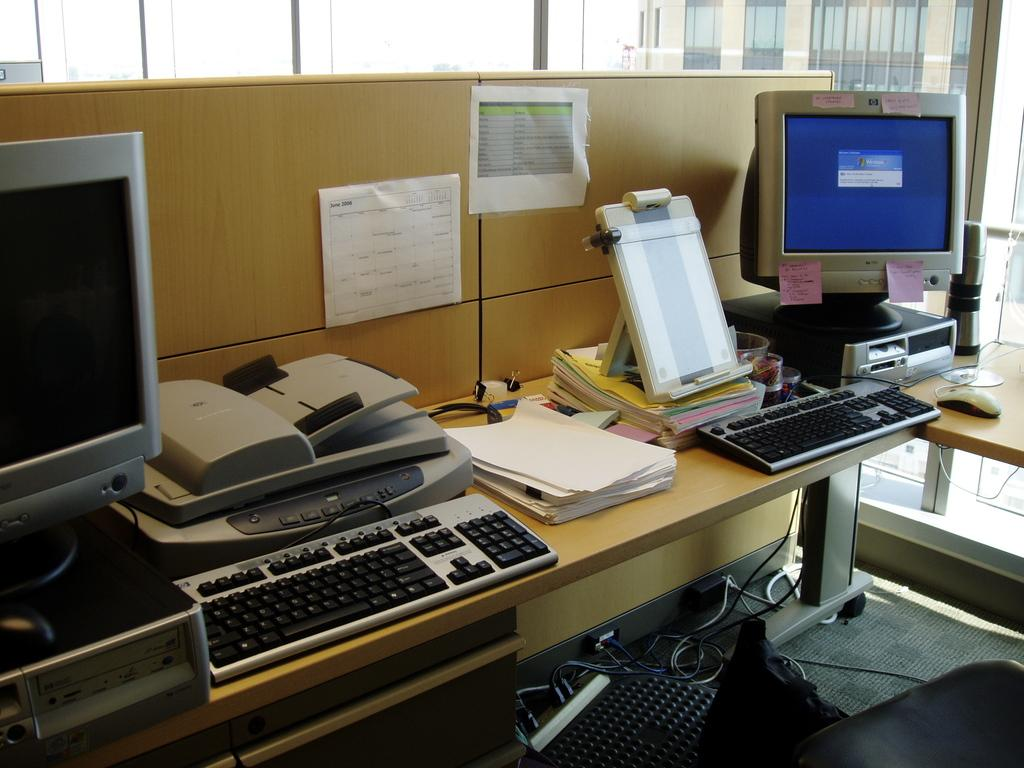How many monitors are visible in the image? There are two monitors in the image. What other input devices are present in the image? There are two keyboards and a mouse in the image. What type of items can be seen on the table? Books, papers, and a scanner are present on the table. What is the location of the electrical device in the image? The electrical device is on the floor. What can be seen in the background of the image? There is a building in the background of the image. What type of juice is being poured from the cup in the image? There is no cup or juice present in the image. How does the pain affect the person in the image? There is no person or indication of pain in the image. 